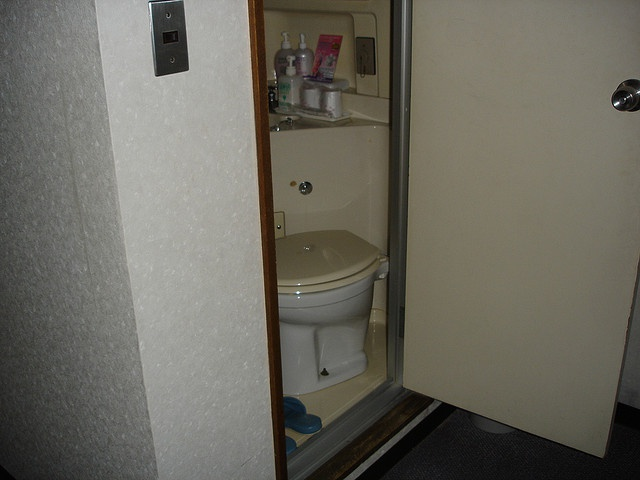Describe the objects in this image and their specific colors. I can see toilet in black, gray, and darkgreen tones, bottle in black and gray tones, and sink in black and gray tones in this image. 